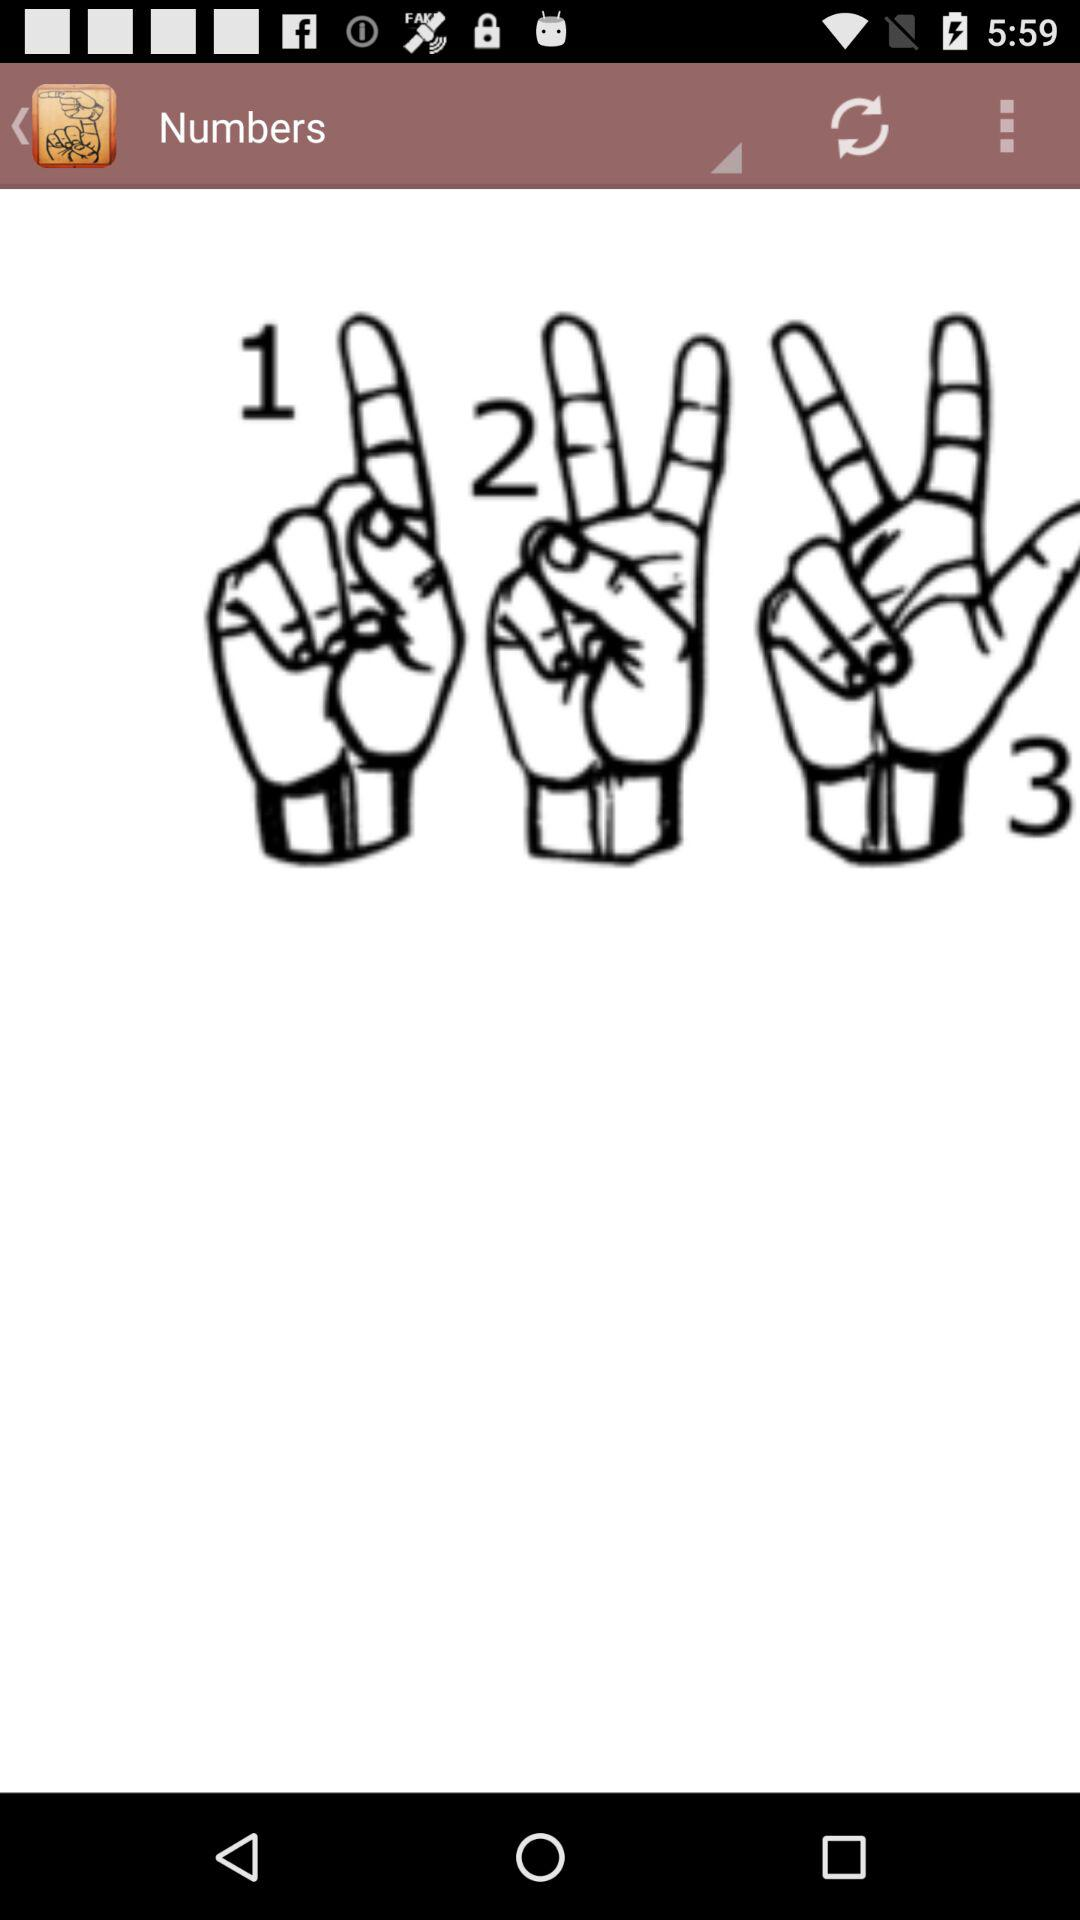How many hands are holding numbers?
Answer the question using a single word or phrase. 3 